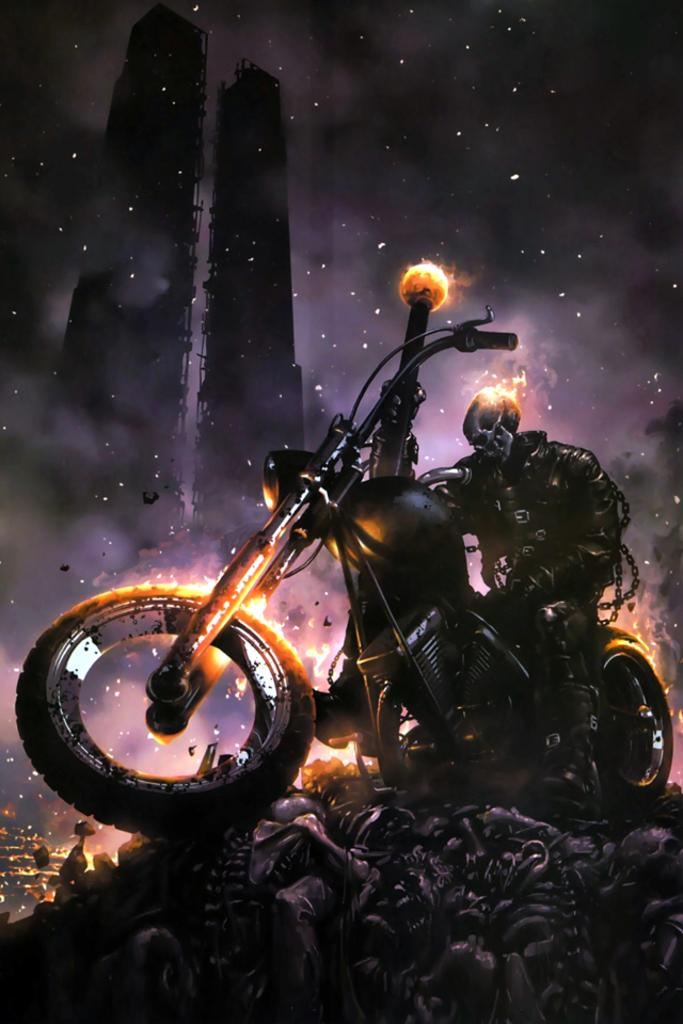What is the person in the image doing? There is a person on a bike in the image. What can be seen in the image besides the person on the bike? There is fire in the image, as well as buildings and the sky in the background. What type of equipment is visible at the bottom of the image? There is equipment at the bottom of the image. How does the person on the bike react to the sneeze in the image? There is no sneeze present in the image, so the person on the bike does not react to it. 